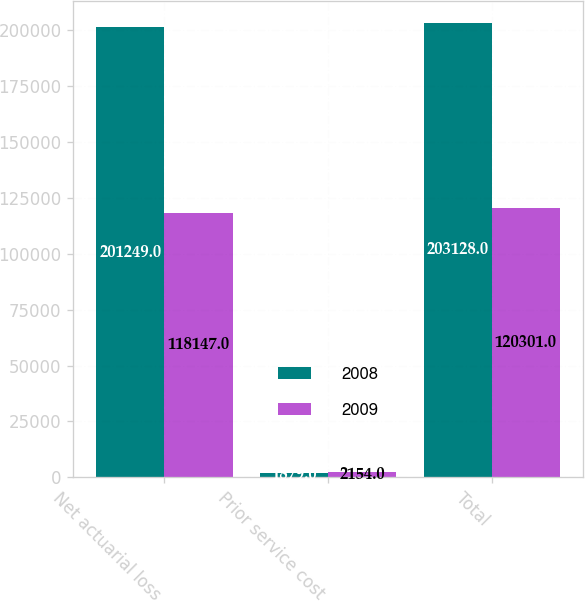Convert chart to OTSL. <chart><loc_0><loc_0><loc_500><loc_500><stacked_bar_chart><ecel><fcel>Net actuarial loss<fcel>Prior service cost<fcel>Total<nl><fcel>2008<fcel>201249<fcel>1879<fcel>203128<nl><fcel>2009<fcel>118147<fcel>2154<fcel>120301<nl></chart> 